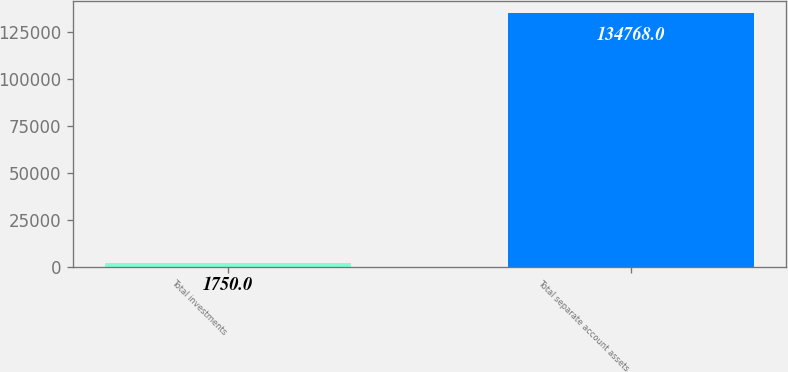Convert chart to OTSL. <chart><loc_0><loc_0><loc_500><loc_500><bar_chart><fcel>Total investments<fcel>Total separate account assets<nl><fcel>1750<fcel>134768<nl></chart> 